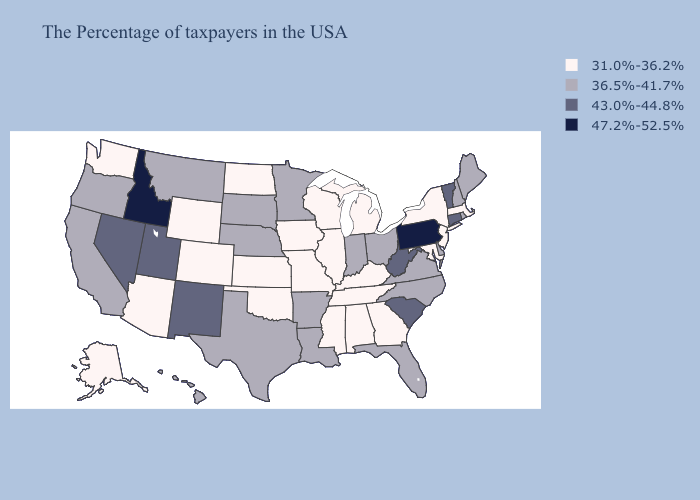Does Missouri have the lowest value in the USA?
Answer briefly. Yes. Among the states that border Illinois , which have the lowest value?
Quick response, please. Kentucky, Wisconsin, Missouri, Iowa. Does Illinois have the same value as Pennsylvania?
Quick response, please. No. Does Iowa have the highest value in the USA?
Write a very short answer. No. What is the lowest value in states that border Ohio?
Keep it brief. 31.0%-36.2%. Name the states that have a value in the range 43.0%-44.8%?
Quick response, please. Vermont, Connecticut, South Carolina, West Virginia, New Mexico, Utah, Nevada. What is the value of Michigan?
Keep it brief. 31.0%-36.2%. Which states have the highest value in the USA?
Keep it brief. Pennsylvania, Idaho. What is the lowest value in the USA?
Short answer required. 31.0%-36.2%. Among the states that border Montana , which have the highest value?
Keep it brief. Idaho. Does Wyoming have a lower value than Delaware?
Short answer required. Yes. Does the first symbol in the legend represent the smallest category?
Answer briefly. Yes. Name the states that have a value in the range 47.2%-52.5%?
Be succinct. Pennsylvania, Idaho. Name the states that have a value in the range 36.5%-41.7%?
Answer briefly. Maine, Rhode Island, New Hampshire, Delaware, Virginia, North Carolina, Ohio, Florida, Indiana, Louisiana, Arkansas, Minnesota, Nebraska, Texas, South Dakota, Montana, California, Oregon, Hawaii. 